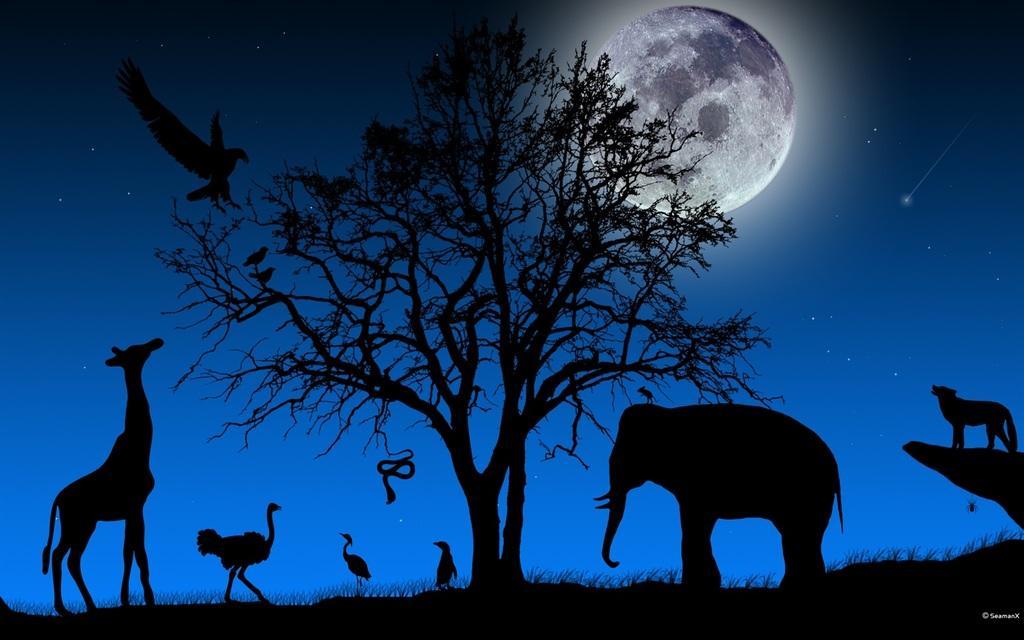Describe this image in one or two sentences. Here in this picture we can see dark animated animals like giraffe, eagle, snake, elephant, birds and a tiger all present over there and we can also see grass on the ground and we can see tree in the middle and we can see moon and stars over there. 